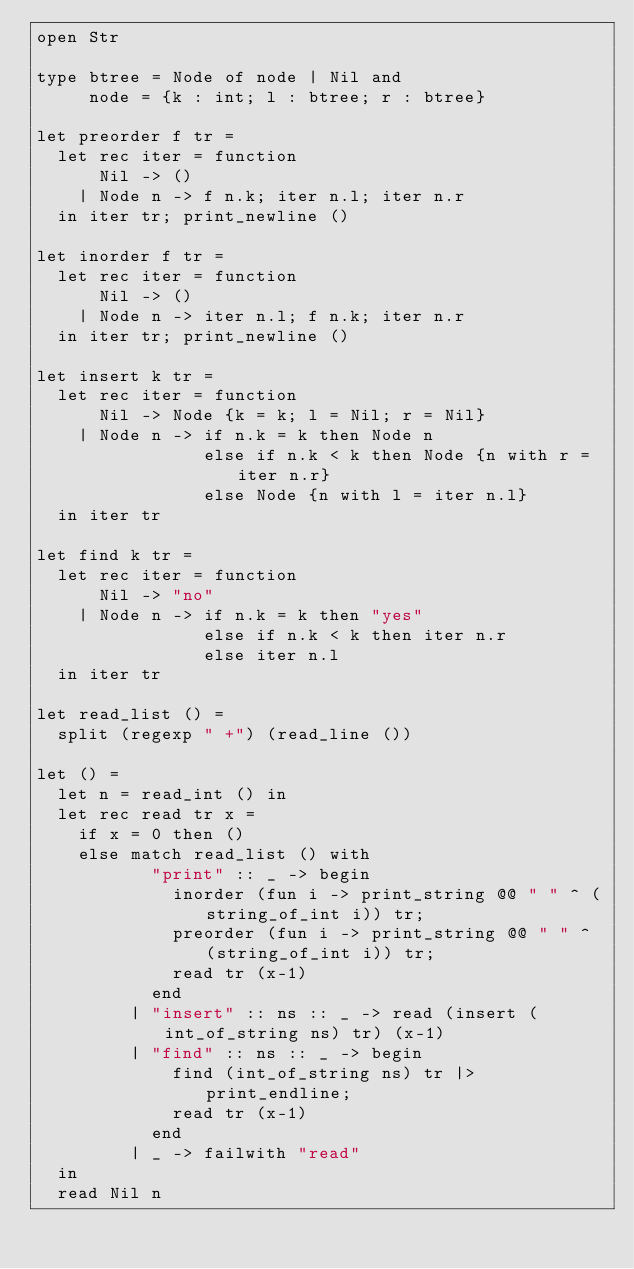Convert code to text. <code><loc_0><loc_0><loc_500><loc_500><_OCaml_>open Str

type btree = Node of node | Nil and
     node = {k : int; l : btree; r : btree}

let preorder f tr =
  let rec iter = function
      Nil -> ()
    | Node n -> f n.k; iter n.l; iter n.r
  in iter tr; print_newline ()
  
let inorder f tr =
  let rec iter = function
      Nil -> ()
    | Node n -> iter n.l; f n.k; iter n.r
  in iter tr; print_newline ()

let insert k tr =
  let rec iter = function
      Nil -> Node {k = k; l = Nil; r = Nil}
    | Node n -> if n.k = k then Node n
                else if n.k < k then Node {n with r = iter n.r}
                else Node {n with l = iter n.l}
  in iter tr

let find k tr =
  let rec iter = function
      Nil -> "no"
    | Node n -> if n.k = k then "yes"
                else if n.k < k then iter n.r
                else iter n.l
  in iter tr

let read_list () =
  split (regexp " +") (read_line ())

let () =
  let n = read_int () in
  let rec read tr x =
    if x = 0 then ()
    else match read_list () with
           "print" :: _ -> begin
             inorder (fun i -> print_string @@ " " ^ (string_of_int i)) tr;
             preorder (fun i -> print_string @@ " " ^ (string_of_int i)) tr;
             read tr (x-1)
           end
         | "insert" :: ns :: _ -> read (insert (int_of_string ns) tr) (x-1)
         | "find" :: ns :: _ -> begin
             find (int_of_string ns) tr |> print_endline;
             read tr (x-1)
           end
         | _ -> failwith "read"
  in
  read Nil n</code> 